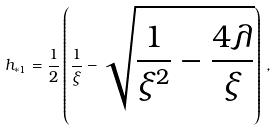Convert formula to latex. <formula><loc_0><loc_0><loc_500><loc_500>h _ { * 1 } = \frac { 1 } { 2 } \left ( \frac { 1 } { \xi } - \sqrt { \frac { 1 } { \xi ^ { 2 } } - \frac { 4 \lambda } { \xi } } \right ) \, ,</formula> 